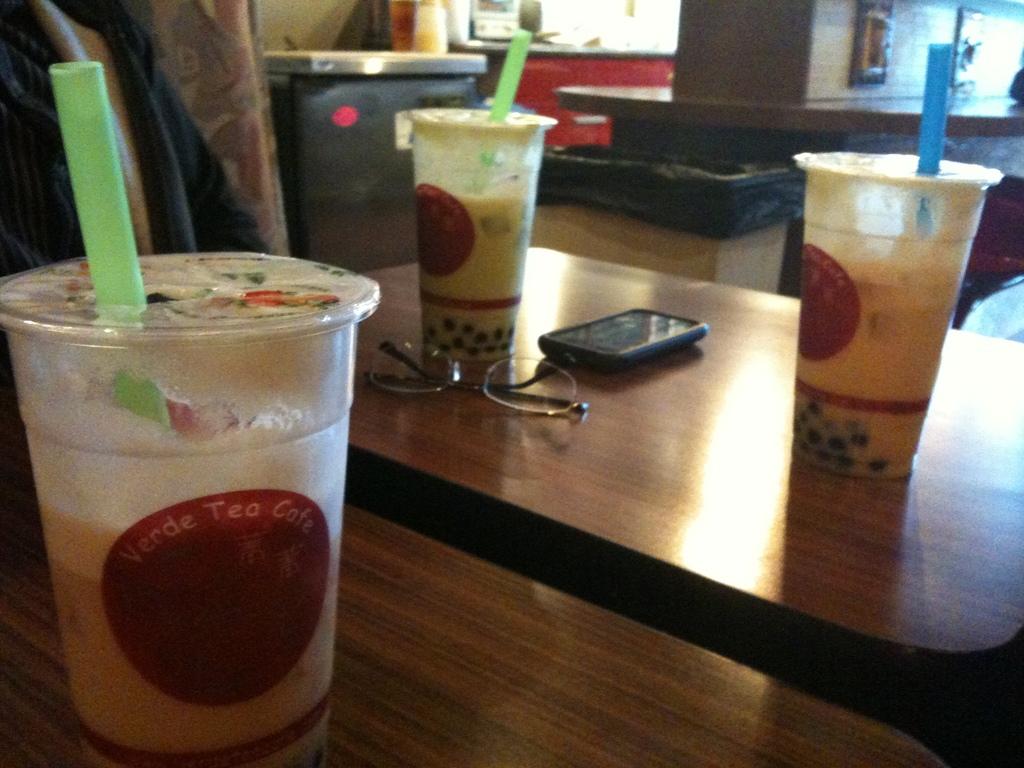What is the name of this cafe?
Your response must be concise. Verde tea cafe. 